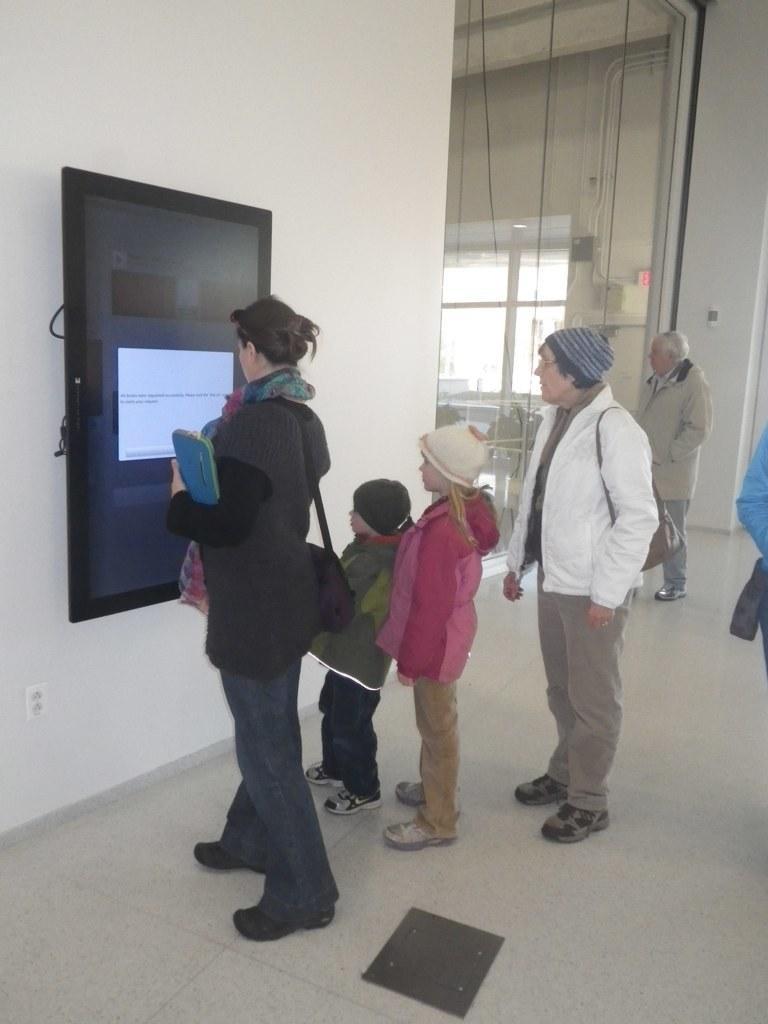Can you describe this image briefly? The picture is clicked inside a room. On the wall there is a screen mounted. In front of the screen a lady is standing. She is holding something. She is carrying a bag. Beside her there are two kids. Here an old man is standing. In the background another old man is walking. In the background there is window, screen. 